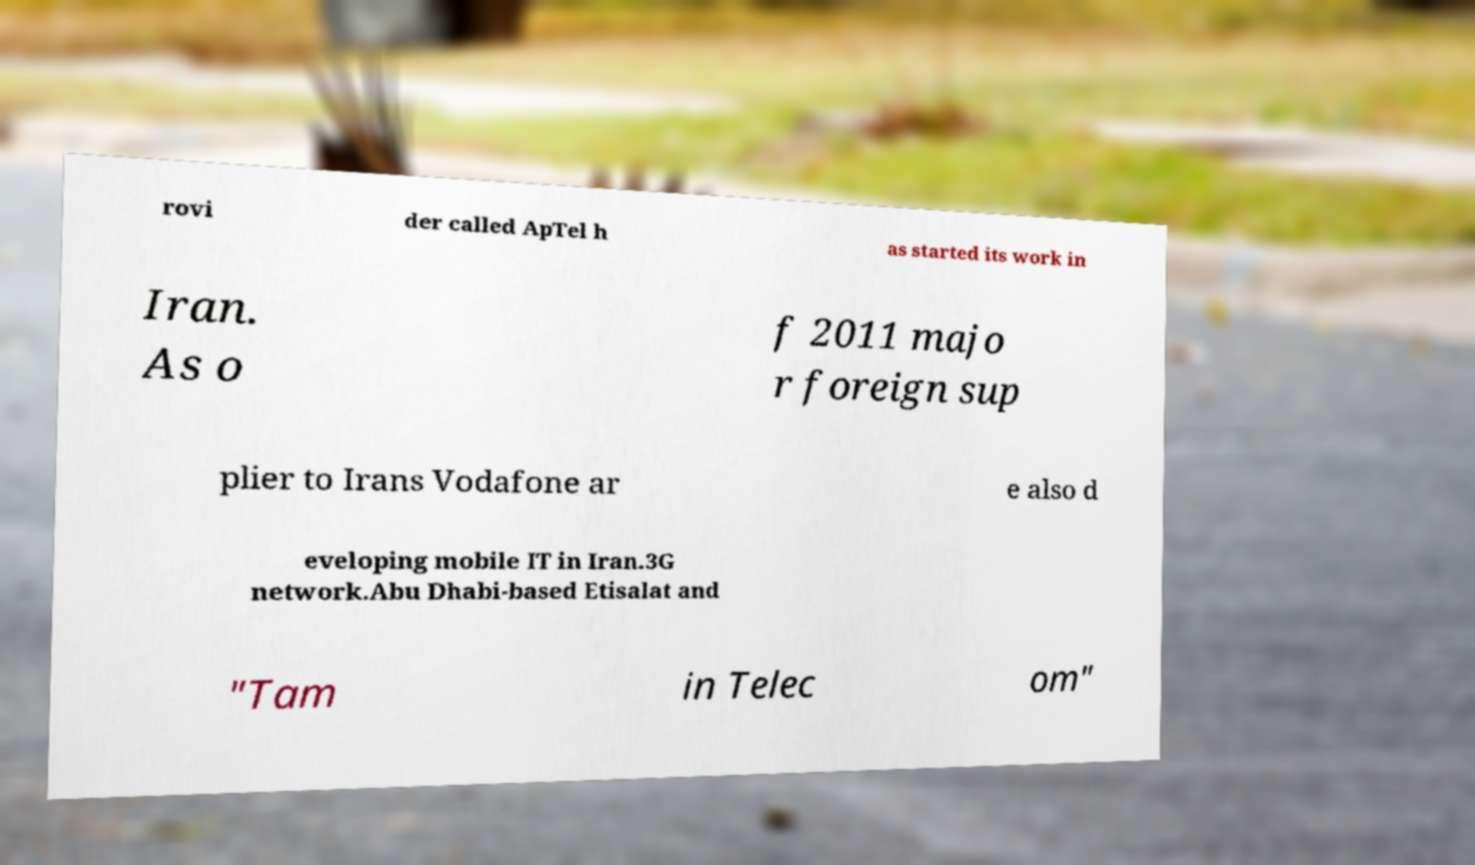Could you assist in decoding the text presented in this image and type it out clearly? rovi der called ApTel h as started its work in Iran. As o f 2011 majo r foreign sup plier to Irans Vodafone ar e also d eveloping mobile IT in Iran.3G network.Abu Dhabi-based Etisalat and "Tam in Telec om" 